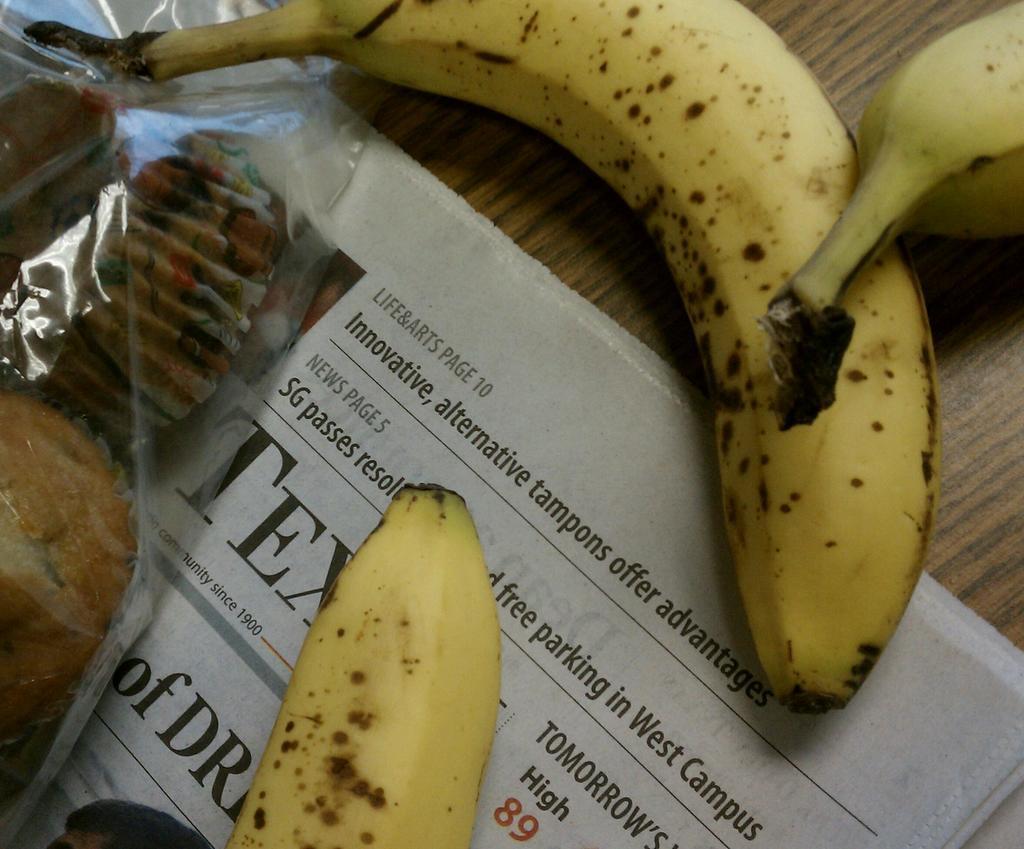Could you give a brief overview of what you see in this image? In this image there is a table and we can see a newspaper, bananas and cupcakes placed on the table. 